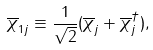Convert formula to latex. <formula><loc_0><loc_0><loc_500><loc_500>\overline { \chi } _ { 1 j } \equiv \frac { 1 } { \sqrt { 2 } } ( \overline { \chi } _ { j } + \overline { \chi } _ { j } ^ { \dagger } ) ,</formula> 